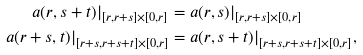Convert formula to latex. <formula><loc_0><loc_0><loc_500><loc_500>a ( r , s + t ) | _ { [ r , r + s ] \times [ 0 , r ] } & = a ( r , s ) | _ { [ r , r + s ] \times [ 0 , r ] } \\ a ( r + s , t ) | _ { [ r + s , r + s + t ] \times [ 0 , r ] } & = a ( r , s + t ) | _ { [ r + s , r + s + t ] \times [ 0 , r ] } ,</formula> 